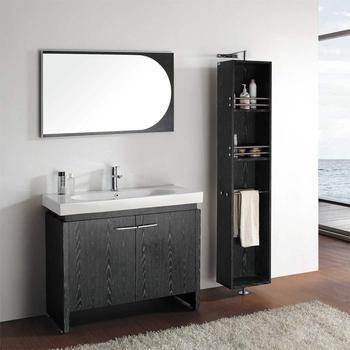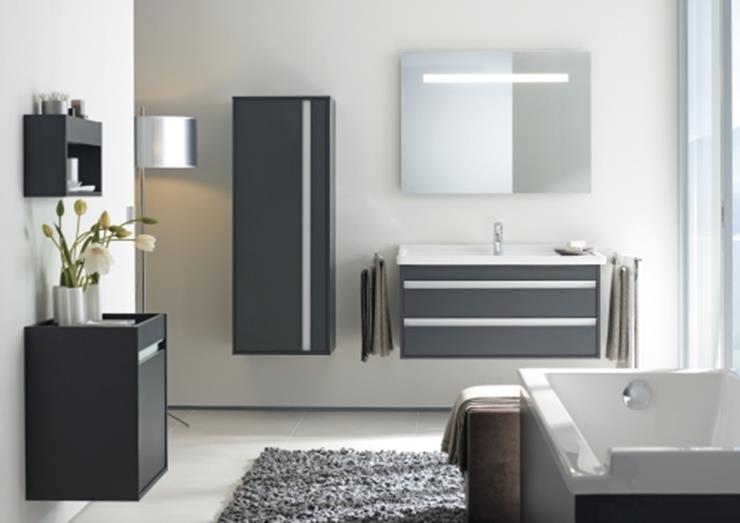The first image is the image on the left, the second image is the image on the right. Examine the images to the left and right. Is the description "Two mirrors hang over the sinks in the image on the right." accurate? Answer yes or no. No. 